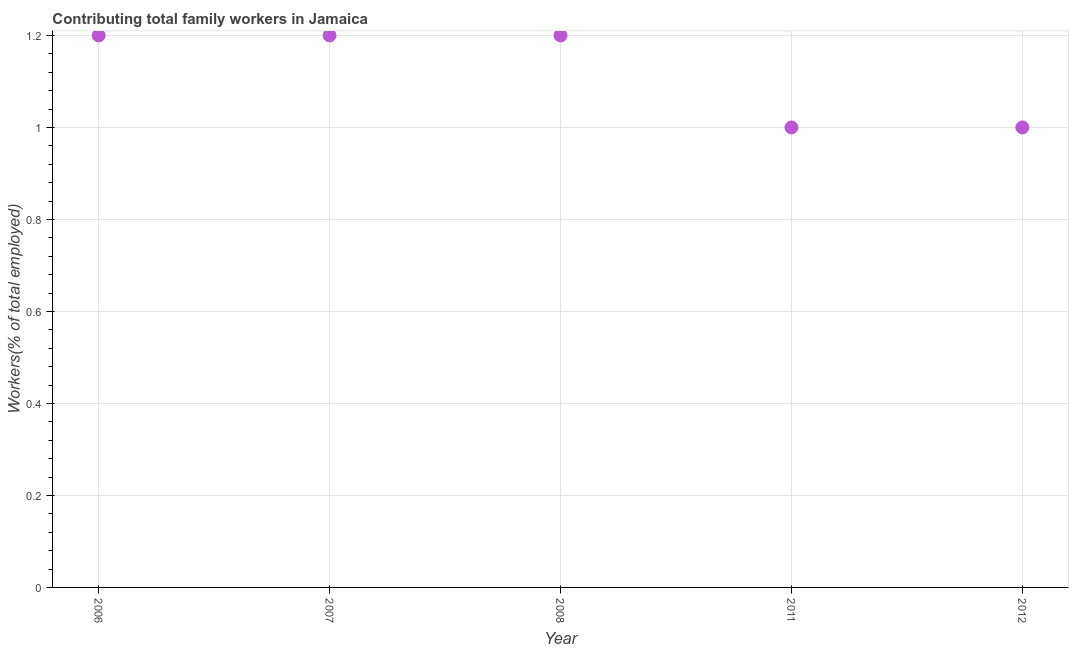What is the contributing family workers in 2007?
Keep it short and to the point. 1.2. Across all years, what is the maximum contributing family workers?
Provide a short and direct response. 1.2. What is the sum of the contributing family workers?
Give a very brief answer. 5.6. What is the average contributing family workers per year?
Ensure brevity in your answer.  1.12. What is the median contributing family workers?
Offer a terse response. 1.2. What is the ratio of the contributing family workers in 2008 to that in 2011?
Your response must be concise. 1.2. Is the difference between the contributing family workers in 2006 and 2008 greater than the difference between any two years?
Provide a short and direct response. No. What is the difference between the highest and the lowest contributing family workers?
Offer a terse response. 0.2. Does the contributing family workers monotonically increase over the years?
Offer a terse response. No. How many dotlines are there?
Give a very brief answer. 1. How many years are there in the graph?
Keep it short and to the point. 5. Are the values on the major ticks of Y-axis written in scientific E-notation?
Keep it short and to the point. No. Does the graph contain any zero values?
Offer a terse response. No. Does the graph contain grids?
Offer a terse response. Yes. What is the title of the graph?
Keep it short and to the point. Contributing total family workers in Jamaica. What is the label or title of the X-axis?
Your response must be concise. Year. What is the label or title of the Y-axis?
Give a very brief answer. Workers(% of total employed). What is the Workers(% of total employed) in 2006?
Give a very brief answer. 1.2. What is the Workers(% of total employed) in 2007?
Provide a short and direct response. 1.2. What is the Workers(% of total employed) in 2008?
Provide a succinct answer. 1.2. What is the Workers(% of total employed) in 2011?
Provide a succinct answer. 1. What is the Workers(% of total employed) in 2012?
Ensure brevity in your answer.  1. What is the difference between the Workers(% of total employed) in 2006 and 2011?
Your answer should be compact. 0.2. What is the difference between the Workers(% of total employed) in 2006 and 2012?
Keep it short and to the point. 0.2. What is the difference between the Workers(% of total employed) in 2007 and 2008?
Your answer should be compact. 0. What is the difference between the Workers(% of total employed) in 2007 and 2011?
Offer a terse response. 0.2. What is the difference between the Workers(% of total employed) in 2007 and 2012?
Offer a very short reply. 0.2. What is the difference between the Workers(% of total employed) in 2008 and 2011?
Provide a succinct answer. 0.2. What is the difference between the Workers(% of total employed) in 2008 and 2012?
Your answer should be compact. 0.2. What is the ratio of the Workers(% of total employed) in 2006 to that in 2007?
Offer a terse response. 1. What is the ratio of the Workers(% of total employed) in 2006 to that in 2008?
Offer a terse response. 1. What is the ratio of the Workers(% of total employed) in 2008 to that in 2012?
Your response must be concise. 1.2. What is the ratio of the Workers(% of total employed) in 2011 to that in 2012?
Ensure brevity in your answer.  1. 